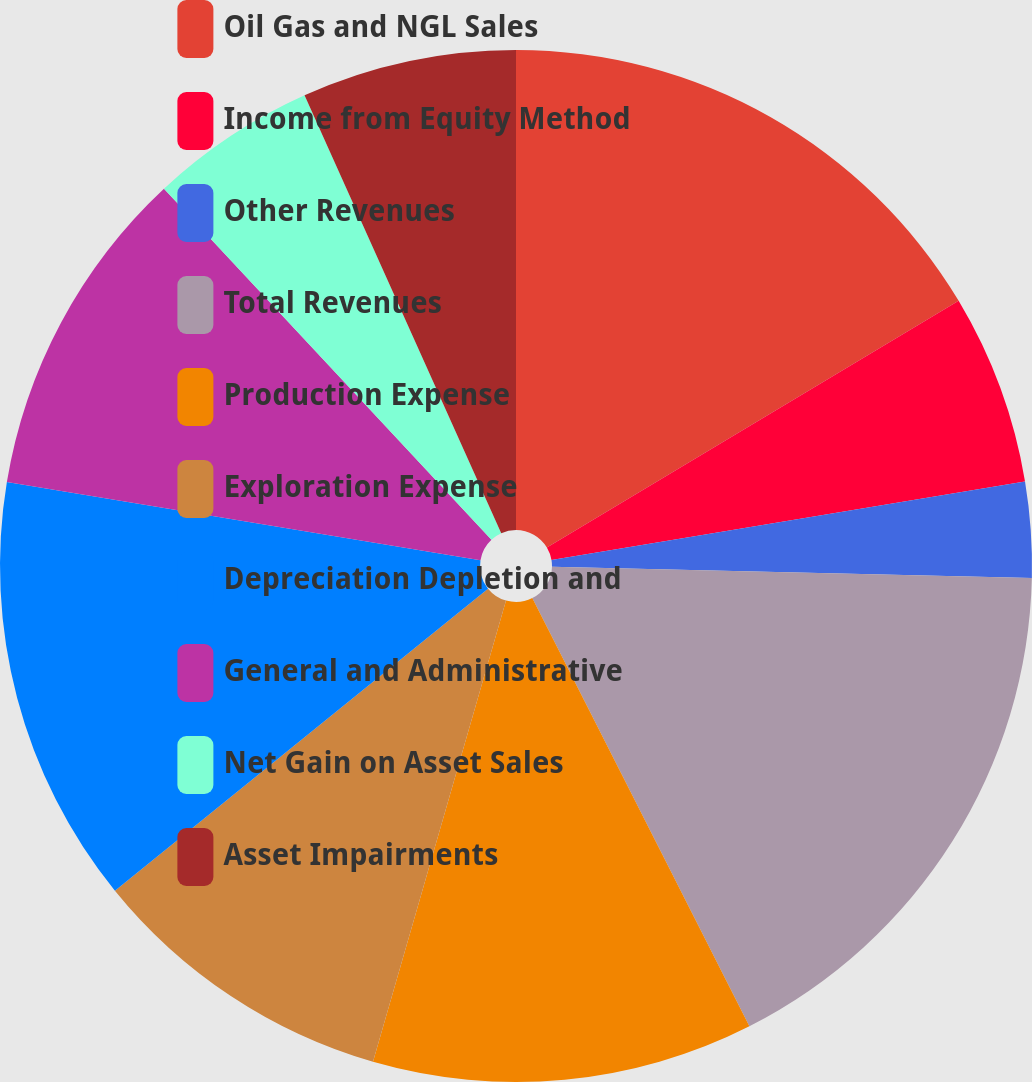Convert chart to OTSL. <chart><loc_0><loc_0><loc_500><loc_500><pie_chart><fcel>Oil Gas and NGL Sales<fcel>Income from Equity Method<fcel>Other Revenues<fcel>Total Revenues<fcel>Production Expense<fcel>Exploration Expense<fcel>Depreciation Depletion and<fcel>General and Administrative<fcel>Net Gain on Asset Sales<fcel>Asset Impairments<nl><fcel>16.41%<fcel>5.97%<fcel>2.99%<fcel>17.16%<fcel>11.94%<fcel>9.7%<fcel>13.43%<fcel>10.45%<fcel>5.23%<fcel>6.72%<nl></chart> 